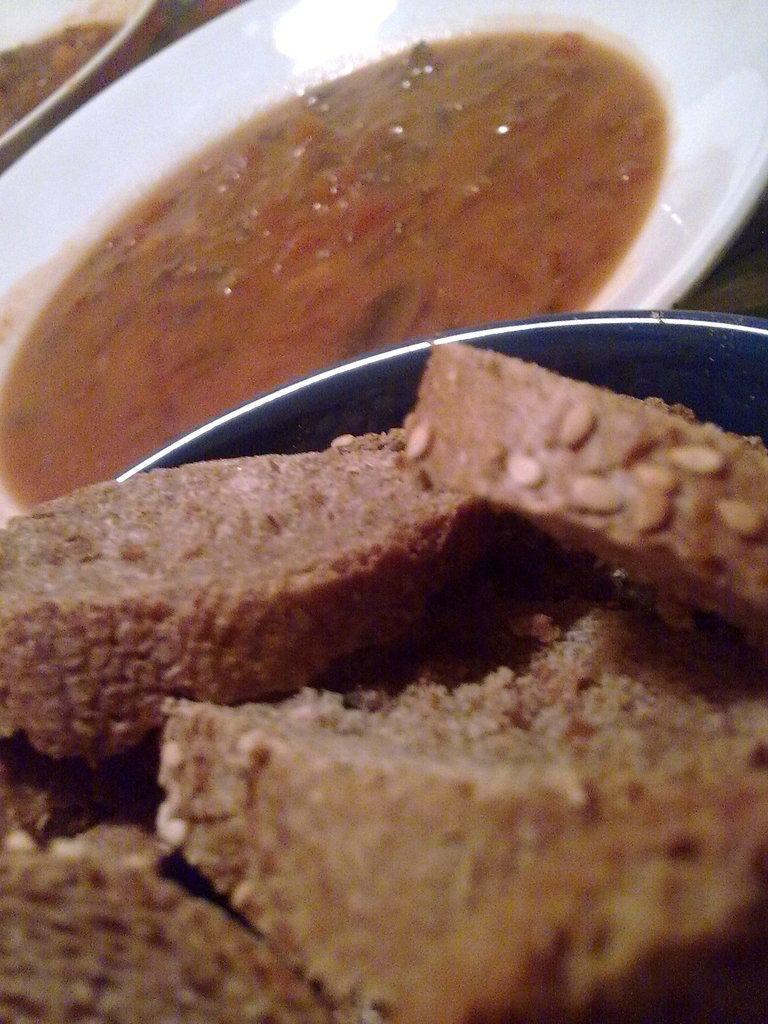How would you summarize this image in a sentence or two? In the center of the image there is a table. On the table,we can see planets,one bowl and some food items. 